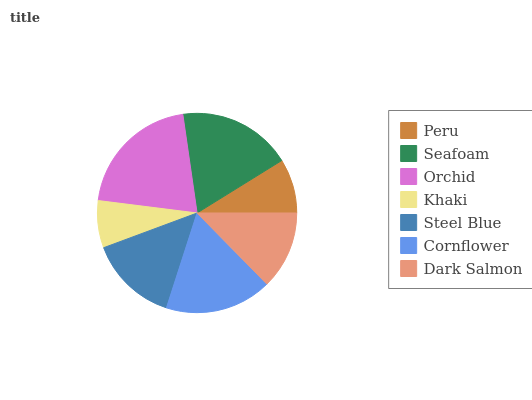Is Khaki the minimum?
Answer yes or no. Yes. Is Orchid the maximum?
Answer yes or no. Yes. Is Seafoam the minimum?
Answer yes or no. No. Is Seafoam the maximum?
Answer yes or no. No. Is Seafoam greater than Peru?
Answer yes or no. Yes. Is Peru less than Seafoam?
Answer yes or no. Yes. Is Peru greater than Seafoam?
Answer yes or no. No. Is Seafoam less than Peru?
Answer yes or no. No. Is Steel Blue the high median?
Answer yes or no. Yes. Is Steel Blue the low median?
Answer yes or no. Yes. Is Khaki the high median?
Answer yes or no. No. Is Peru the low median?
Answer yes or no. No. 